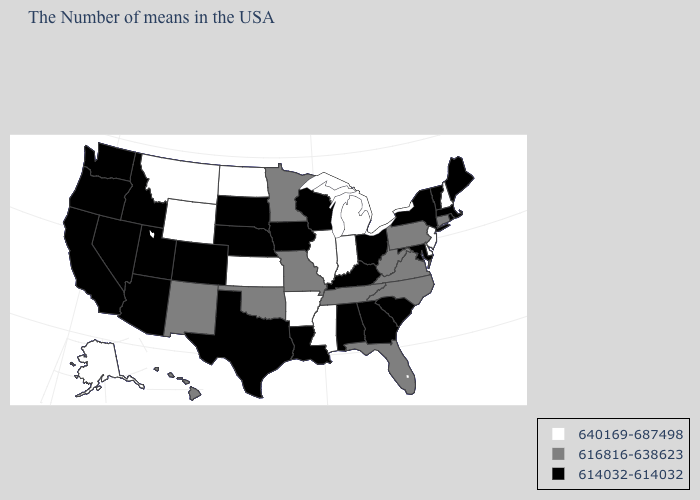What is the value of Louisiana?
Answer briefly. 614032-614032. Name the states that have a value in the range 616816-638623?
Answer briefly. Connecticut, Pennsylvania, Virginia, North Carolina, West Virginia, Florida, Tennessee, Missouri, Minnesota, Oklahoma, New Mexico, Hawaii. What is the value of Maryland?
Keep it brief. 614032-614032. What is the lowest value in states that border South Dakota?
Write a very short answer. 614032-614032. Among the states that border Tennessee , does Missouri have the lowest value?
Quick response, please. No. Does Tennessee have the highest value in the USA?
Quick response, please. No. What is the value of Texas?
Concise answer only. 614032-614032. Does Maryland have the lowest value in the South?
Keep it brief. Yes. What is the value of Alabama?
Concise answer only. 614032-614032. Among the states that border Nevada , which have the highest value?
Keep it brief. Utah, Arizona, Idaho, California, Oregon. Name the states that have a value in the range 616816-638623?
Quick response, please. Connecticut, Pennsylvania, Virginia, North Carolina, West Virginia, Florida, Tennessee, Missouri, Minnesota, Oklahoma, New Mexico, Hawaii. What is the value of Virginia?
Quick response, please. 616816-638623. Name the states that have a value in the range 614032-614032?
Write a very short answer. Maine, Massachusetts, Rhode Island, Vermont, New York, Maryland, South Carolina, Ohio, Georgia, Kentucky, Alabama, Wisconsin, Louisiana, Iowa, Nebraska, Texas, South Dakota, Colorado, Utah, Arizona, Idaho, Nevada, California, Washington, Oregon. What is the lowest value in states that border North Carolina?
Be succinct. 614032-614032. Among the states that border Alabama , which have the lowest value?
Write a very short answer. Georgia. 